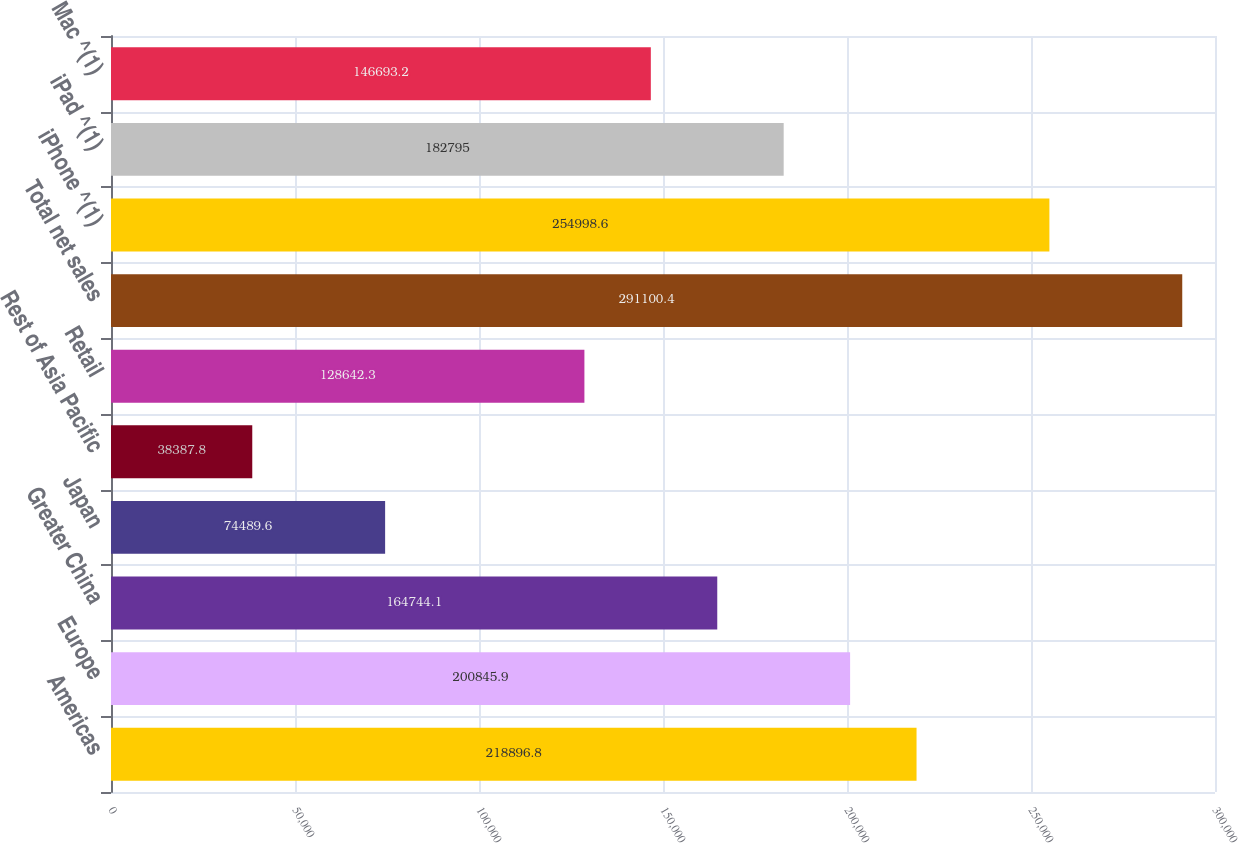<chart> <loc_0><loc_0><loc_500><loc_500><bar_chart><fcel>Americas<fcel>Europe<fcel>Greater China<fcel>Japan<fcel>Rest of Asia Pacific<fcel>Retail<fcel>Total net sales<fcel>iPhone ^(1)<fcel>iPad ^(1)<fcel>Mac ^(1)<nl><fcel>218897<fcel>200846<fcel>164744<fcel>74489.6<fcel>38387.8<fcel>128642<fcel>291100<fcel>254999<fcel>182795<fcel>146693<nl></chart> 